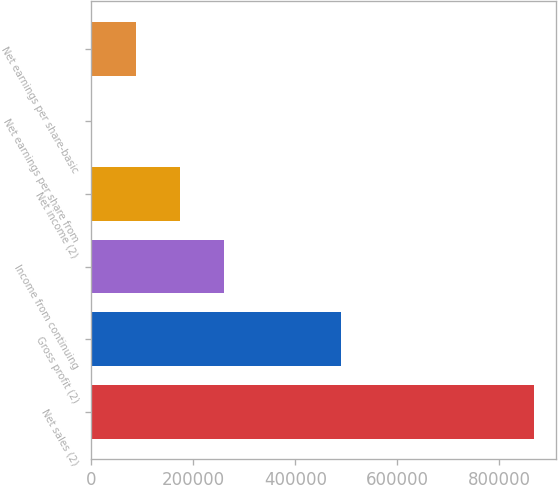<chart> <loc_0><loc_0><loc_500><loc_500><bar_chart><fcel>Net sales (2)<fcel>Gross profit (2)<fcel>Income from continuing<fcel>Net income (2)<fcel>Net earnings per share from<fcel>Net earnings per share-basic<nl><fcel>868728<fcel>489437<fcel>260620<fcel>173748<fcel>2.78<fcel>86875.3<nl></chart> 